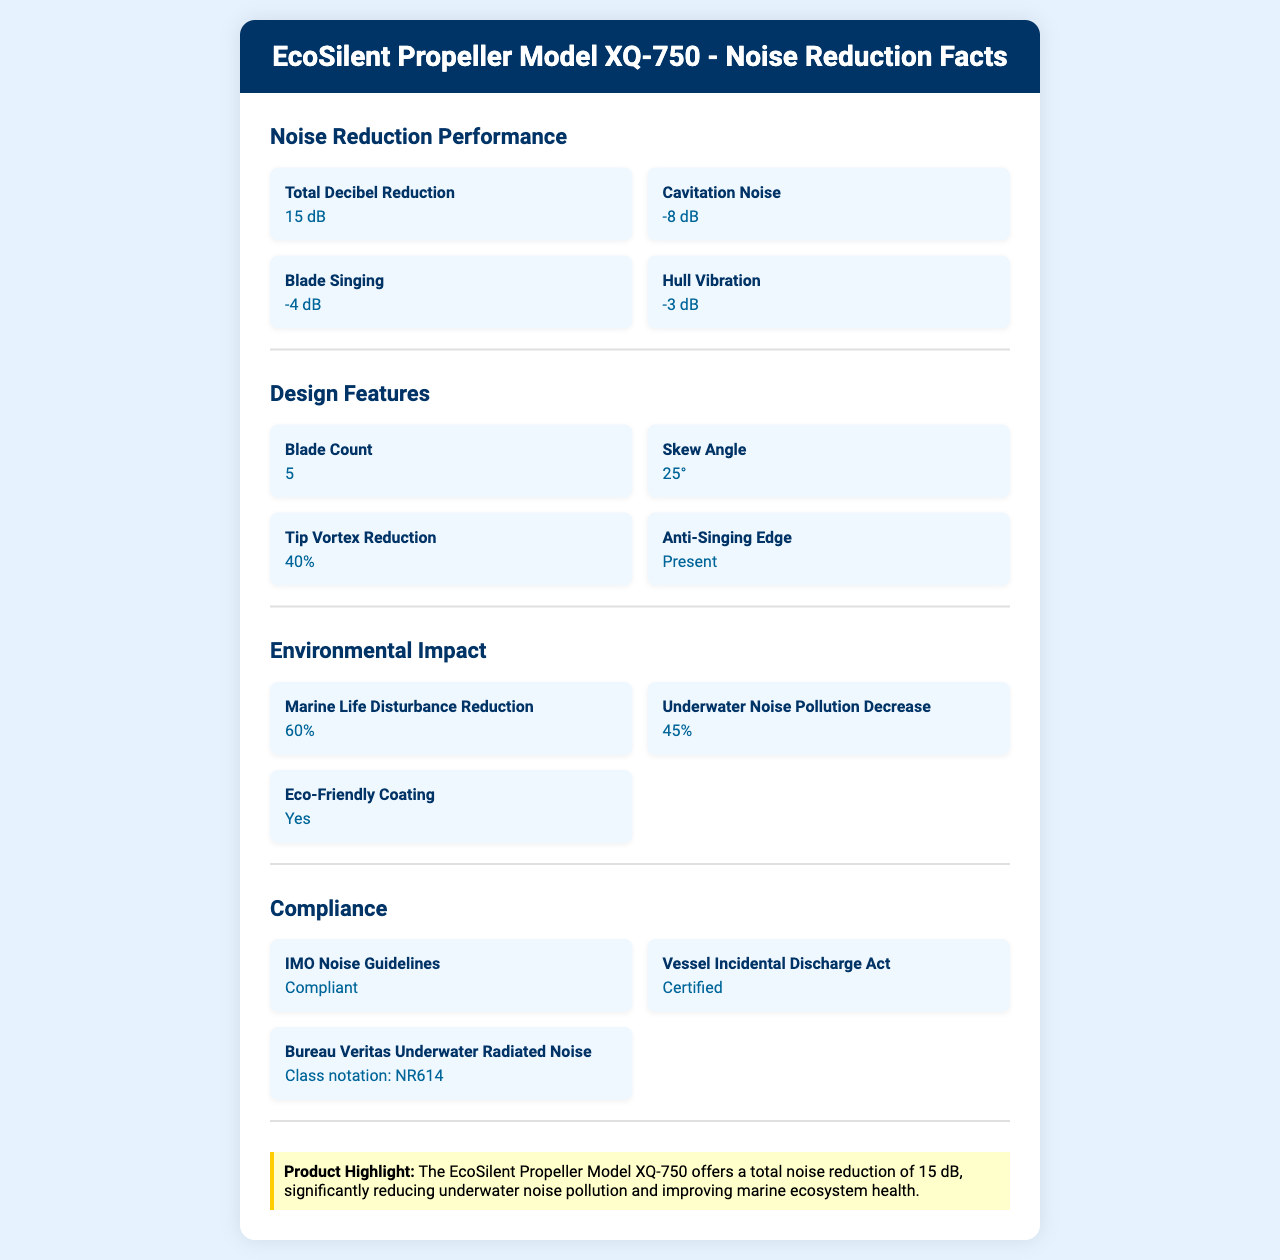What is the total decibel reduction achieved by the EcoSilent Propeller Model XQ-750? The document states that the total decibel reduction for the EcoSilent Propeller Model XQ-750 is 15 dB.
Answer: 15 dB Which material has the highest composition percentage in the EcoSilent Propeller Model XQ-750? A. Stainless Steel B. Nickel Aluminum Bronze C. Composite Materials D. Titanium The document indicates the material composition as 65% Nickel Aluminum Bronze, which is the highest among the listed materials.
Answer: B. Nickel Aluminum Bronze What is the maximum speed achievable with the EcoSilent Propeller Model XQ-750? The section on performance metrics specifies that the maximum speed is 25 knots.
Answer: 25 knots Does the EcoSilent Propeller Model XQ-750 comply with IMO noise guidelines? The document states that the propeller complies with IMO noise guidelines.
Answer: Yes What percentage of the EcoSilent Propeller Model XQ-750 is recyclable? The maintenance section mentions that 85% of the propeller is recyclable.
Answer: 85% How much is the fuel efficiency improvement with the EcoSilent Propeller Model XQ-750? According to the performance metrics, the fuel efficiency improvement is 8%.
Answer: 8% Is there an available retrofit option for the EcoSilent Propeller Model XQ-750? The document specifies that there is an available retrofit option.
Answer: Yes By how many decibels does the EcoSilent Propeller Model XQ-750 reduce cavitation noise? The noise reduction section lists an 8 dB reduction in cavitation noise.
Answer: 8 dB What is the skew angle of the blades in the EcoSilent Propeller Model XQ-750? The design features section mentions a skew angle of 25°.
Answer: 25° Summarize the main features of the EcoSilent Propeller Model XQ-750. The document provides details on the propeller's noise reduction, material composition, design features, environmental impact, compliance, and maintenance. Significant reductions in underwater noise and fuel efficiency improvements are highlighted, making it suitable for various vessels and environmentally friendly.
Answer: The EcoSilent Propeller Model XQ-750 offers significant noise reduction with a total decibel reduction of 15 dB. It is composed mainly of Nickel Aluminum Bronze and Stainless Steel and features design elements such as a 5-blade count and a 25° skew angle. The propeller enhances environmental impact by reducing underwater noise pollution and marine life disturbance, complies with various noise guidelines, and offers a fuel efficiency improvement of 8%. It is compatible with multiple vessel types and has a high recyclability rate of 85%. How many blade singing decibels are reduced by the EcoSilent Propeller Model XQ-750? The noise reduction section indicates a 4 dB reduction for blade singing noise.
Answer: 4 dB Which class notation does the EcoSilent Propeller Model XQ-750 comply with regarding underwater radiated noise? I. NR624 II. NR611 III. NR614 IV. NR619 The compliance section lists the Bureau Veritas Underwater Radiated Noise class notation as NR614.
Answer: III. NR614 What is the vessel type compatibility of the EcoSilent Propeller Model XQ-750? The document specifies that the propeller is compatible with Container ships, Tankers, and Cruise ships.
Answer: Container ships, Tankers, Cruise ships What is the average lifespan of the EcoSilent Propeller Model XQ-750? According to the maintenance section, the average lifespan is 10 years.
Answer: 10 years Is there an anti-singing edge present in the EcoSilent Propeller Model XQ-750 design? The design features section mentions the presence of an anti-singing edge.
Answer: Yes What is the carbon credit potential of the EcoSilent Propeller Model XQ-750? The cost analysis section states that there is carbon credit potential.
Answer: Yes Can the exact percentage of fuel savings achieved over 5 years be extrapolated from the document? Although the document states a 12% long-term savings over 5 years, it does not provide the baseline fuel consumption needed to calculate the exact fuel savings.
Answer: Not enough information 